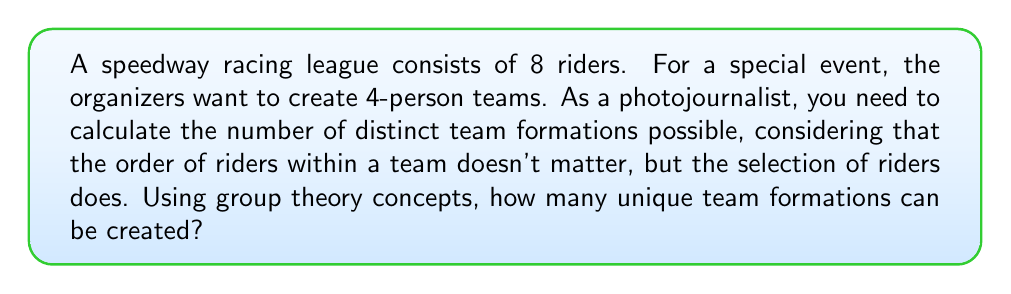Provide a solution to this math problem. To solve this problem, we can use the concept of group actions and orbits from group theory. Let's approach this step-by-step:

1) First, we need to recognize that this is a combination problem. We are selecting 4 riders from a group of 8, where the order doesn't matter.

2) This scenario can be represented by the action of the symmetric group $S_4$ (permutations of 4 elements) on the set of all 4-element subsets of the 8 riders.

3) The number of 4-element subsets of 8 riders is given by the combination formula:

   $$\binom{8}{4} = \frac{8!}{4!(8-4)!} = \frac{8!}{4!4!}$$

4) However, each subset can be arranged in 4! ways, which are all considered the same team in our problem. This is where group theory comes in.

5) The action of $S_4$ on each 4-element subset creates an orbit. The size of each orbit is 4! (since all permutations of 4 elements are possible).

6) By the Orbit-Stabilizer theorem, the number of orbits (which represents our distinct team formations) is equal to the total number of 4-element subsets divided by the size of each orbit:

   $$\text{Number of distinct teams} = \frac{\text{Number of 4-element subsets}}{\text{Size of each orbit}} = \frac{\binom{8}{4}}{4!}$$

7) Let's calculate this:

   $$\frac{\binom{8}{4}}{4!} = \frac{8!}{4!4!4!} = \frac{8 \cdot 7 \cdot 6 \cdot 5}{4 \cdot 3 \cdot 2 \cdot 1} = 70$$

Therefore, there are 70 distinct team formations possible.
Answer: 70 distinct team formations 